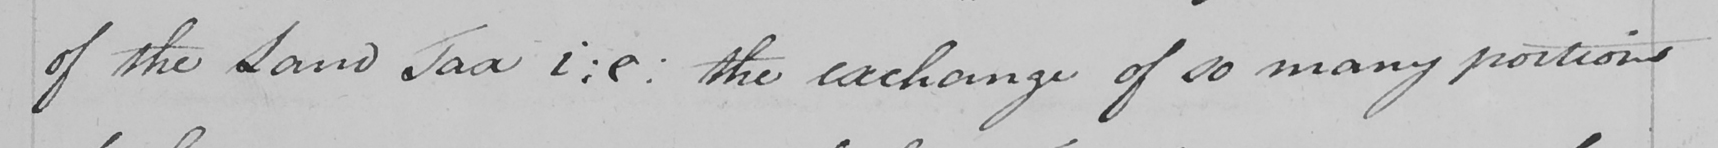Please transcribe the handwritten text in this image. of the Land Tax i : e :  the exchange of so many portions 